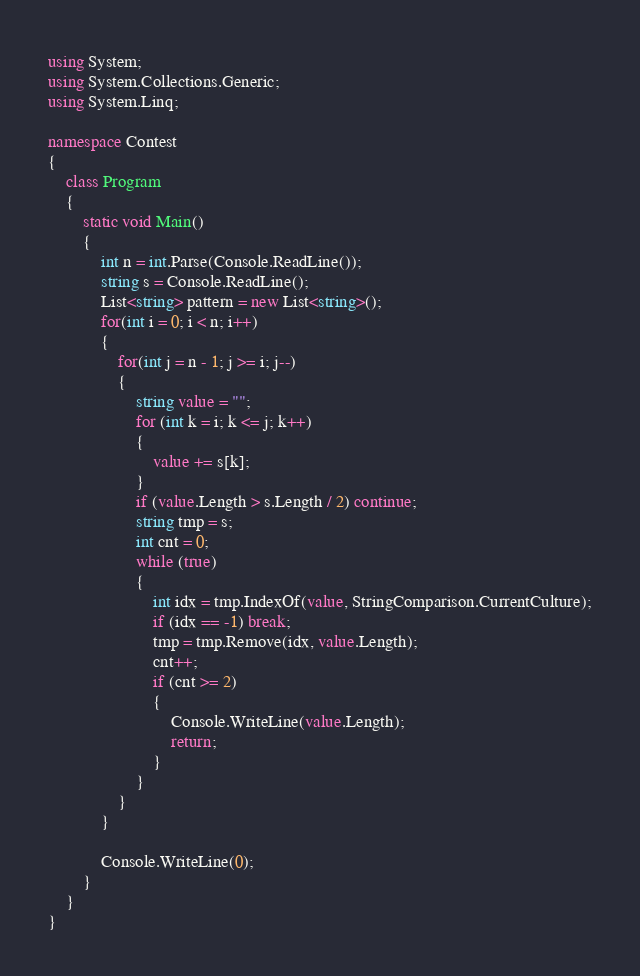Convert code to text. <code><loc_0><loc_0><loc_500><loc_500><_C#_>using System;
using System.Collections.Generic;
using System.Linq;

namespace Contest
{
    class Program
    {
        static void Main()
        {
            int n = int.Parse(Console.ReadLine());
            string s = Console.ReadLine();
            List<string> pattern = new List<string>();
            for(int i = 0; i < n; i++)
            {
                for(int j = n - 1; j >= i; j--)
                {
                    string value = "";
                    for (int k = i; k <= j; k++)
                    {
                        value += s[k];
                    }
                    if (value.Length > s.Length / 2) continue;
                    string tmp = s;
                    int cnt = 0;
                    while (true)
                    {
                        int idx = tmp.IndexOf(value, StringComparison.CurrentCulture);
                        if (idx == -1) break;
                        tmp = tmp.Remove(idx, value.Length);
                        cnt++;
                        if (cnt >= 2)
                        {
                            Console.WriteLine(value.Length);
                            return;
                        }
                    }
                }
            }

            Console.WriteLine(0);
        }
    }
}
</code> 